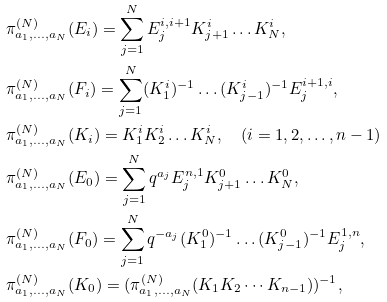<formula> <loc_0><loc_0><loc_500><loc_500>& \pi _ { a _ { 1 } , \dots , a _ { N } } ^ { ( N ) } ( E _ { i } ) = \sum _ { j = 1 } ^ { N } E _ { j } ^ { i , i + 1 } K _ { j + 1 } ^ { i } \dots K _ { N } ^ { i } , \\ & \pi _ { a _ { 1 } , \dots , a _ { N } } ^ { ( N ) } ( F _ { i } ) = \sum _ { j = 1 } ^ { N } ( K _ { 1 } ^ { i } ) ^ { - 1 } \dots ( K _ { j - 1 } ^ { i } ) ^ { - 1 } E _ { j } ^ { i + 1 , i } , \\ & \pi _ { a _ { 1 } , \dots , a _ { N } } ^ { ( N ) } ( K _ { i } ) = K ^ { i } _ { 1 } K ^ { i } _ { 2 } \dots K ^ { i } _ { N } , \quad ( i = 1 , 2 , \dots , n - 1 ) \\ & \pi _ { a _ { 1 } , \dots , a _ { N } } ^ { ( N ) } ( E _ { 0 } ) = \sum _ { j = 1 } ^ { N } q ^ { a _ { j } } E _ { j } ^ { n , 1 } K _ { j + 1 } ^ { 0 } \dots K _ { N } ^ { 0 } , \\ & \pi _ { a _ { 1 } , \dots , a _ { N } } ^ { ( N ) } ( F _ { 0 } ) = \sum _ { j = 1 } ^ { N } q ^ { - a _ { j } } ( K _ { 1 } ^ { 0 } ) ^ { - 1 } \dots ( K _ { j - 1 } ^ { 0 } ) ^ { - 1 } E _ { j } ^ { 1 , n } , \\ & \pi _ { a _ { 1 } , \dots , a _ { N } } ^ { ( N ) } ( K _ { 0 } ) = ( \pi _ { a _ { 1 } , \dots , a _ { N } } ^ { ( N ) } ( K _ { 1 } K _ { 2 } \cdots K _ { n - 1 } ) ) ^ { - 1 } ,</formula> 